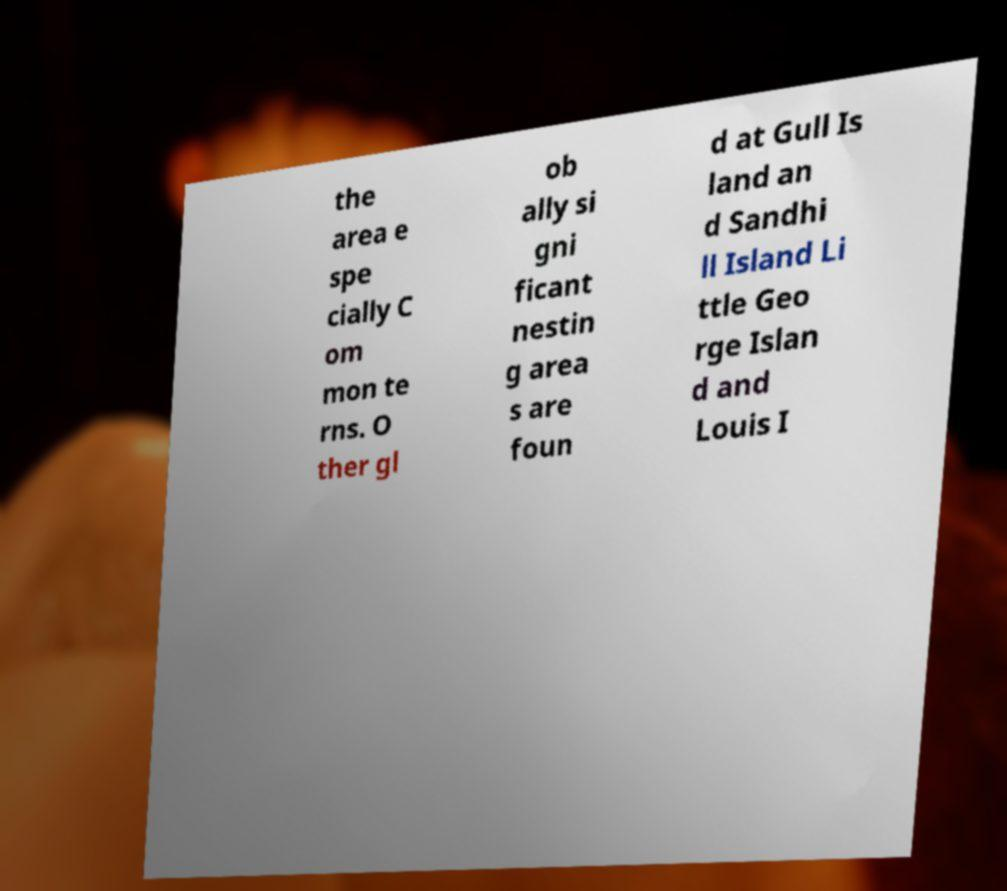Please identify and transcribe the text found in this image. the area e spe cially C om mon te rns. O ther gl ob ally si gni ficant nestin g area s are foun d at Gull Is land an d Sandhi ll Island Li ttle Geo rge Islan d and Louis I 